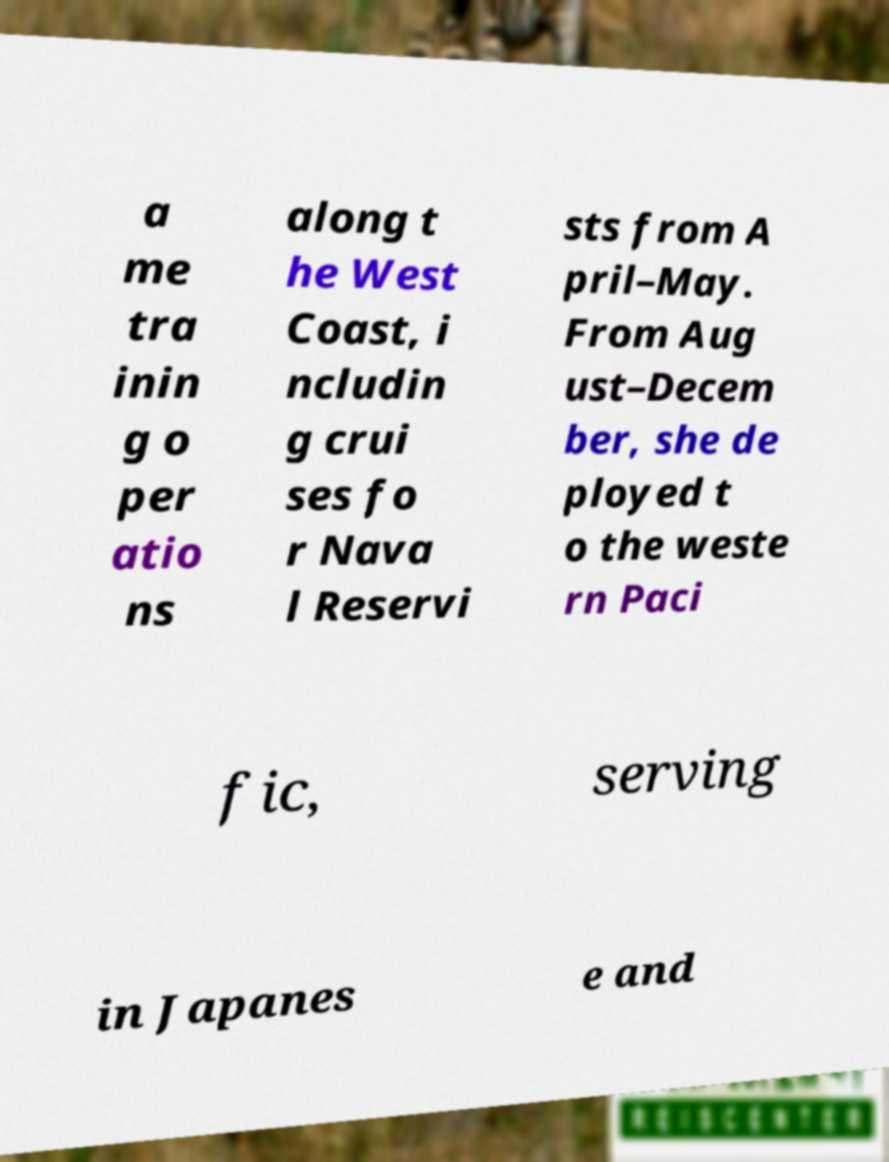I need the written content from this picture converted into text. Can you do that? a me tra inin g o per atio ns along t he West Coast, i ncludin g crui ses fo r Nava l Reservi sts from A pril–May. From Aug ust–Decem ber, she de ployed t o the weste rn Paci fic, serving in Japanes e and 